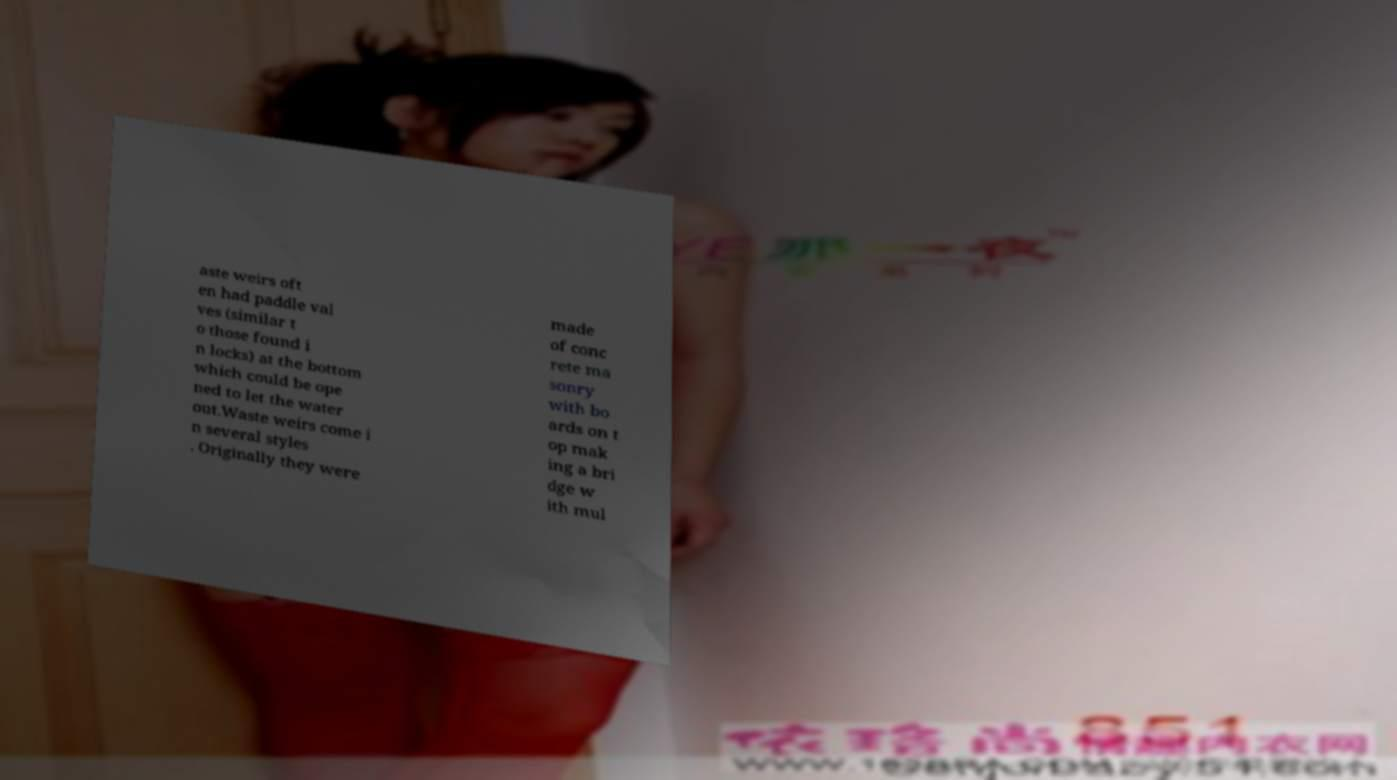For documentation purposes, I need the text within this image transcribed. Could you provide that? aste weirs oft en had paddle val ves (similar t o those found i n locks) at the bottom which could be ope ned to let the water out.Waste weirs come i n several styles . Originally they were made of conc rete ma sonry with bo ards on t op mak ing a bri dge w ith mul 